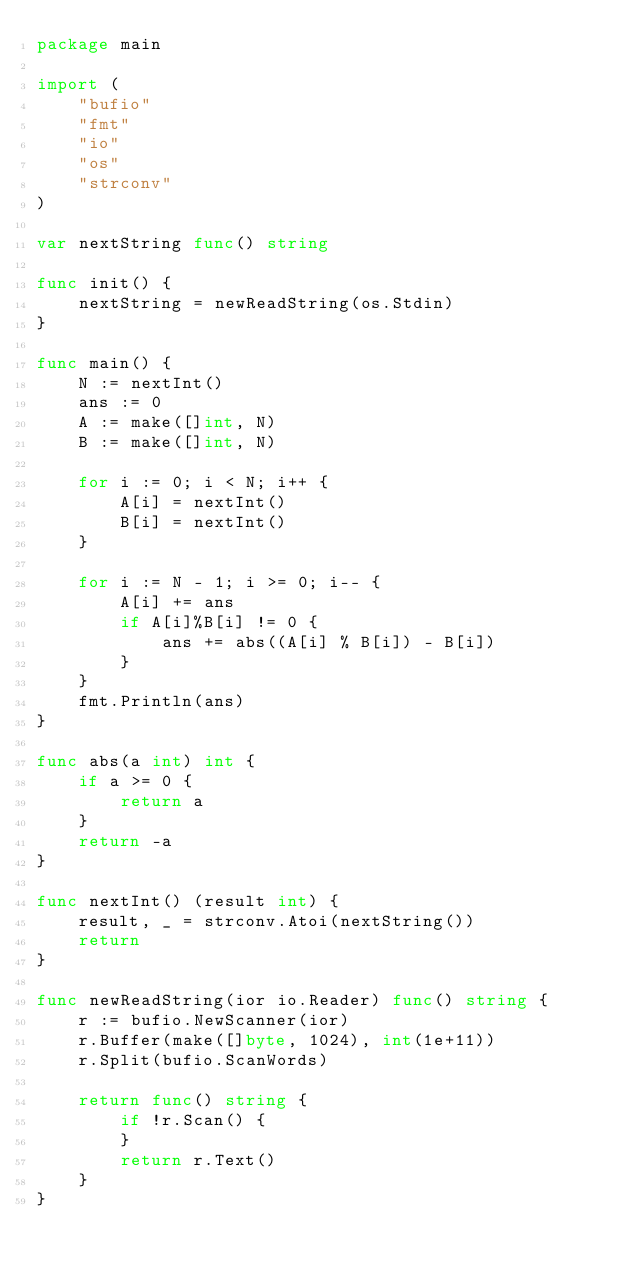Convert code to text. <code><loc_0><loc_0><loc_500><loc_500><_Go_>package main

import (
	"bufio"
	"fmt"
	"io"
	"os"
	"strconv"
)

var nextString func() string

func init() {
	nextString = newReadString(os.Stdin)
}

func main() {
	N := nextInt()
	ans := 0
	A := make([]int, N)
	B := make([]int, N)

	for i := 0; i < N; i++ {
		A[i] = nextInt()
		B[i] = nextInt()
	}

	for i := N - 1; i >= 0; i-- {
		A[i] += ans
		if A[i]%B[i] != 0 {
			ans += abs((A[i] % B[i]) - B[i])
		}
	}
	fmt.Println(ans)
}

func abs(a int) int {
	if a >= 0 {
		return a
	}
	return -a
}

func nextInt() (result int) {
	result, _ = strconv.Atoi(nextString())
	return
}

func newReadString(ior io.Reader) func() string {
	r := bufio.NewScanner(ior)
	r.Buffer(make([]byte, 1024), int(1e+11))
	r.Split(bufio.ScanWords)

	return func() string {
		if !r.Scan() {
		}
		return r.Text()
	}
}
</code> 